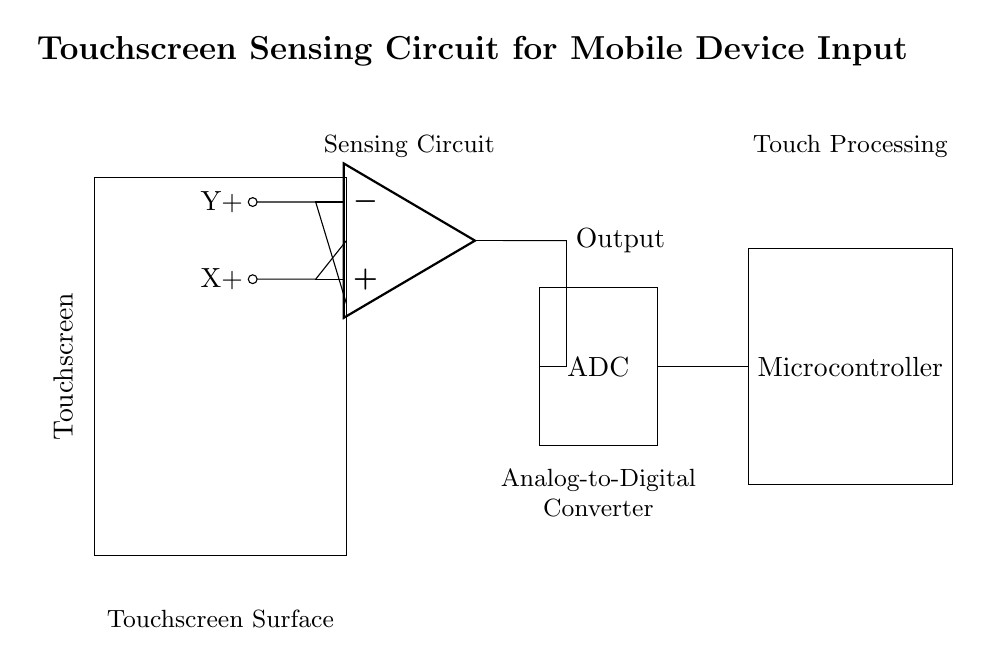What is the main component used for sensing in this circuit? The main component used for sensing is the operational amplifier, which amplifies the signals received from the touchscreen.
Answer: Operational amplifier What is the function of the ADC in this circuit? The ADC (Analog-to-Digital Converter) converts the analog signals outputted by the operational amplifier into digital signals for the microcontroller to process.
Answer: Conversion of signals What are the two input signals connected to the operational amplifier? The two input signals connected to the operational amplifier are X+ and Y+, which correspond to the X and Y coordinates of the touch input.
Answer: X+ and Y+ How does the output from the operational amplifier connect to the ADC? The output from the operational amplifier is connected directly to the ADC through a short connection, allowing for the signal to be processed.
Answer: Direct connection What is the purpose of the microcontroller in this circuit? The microcontroller's purpose is to process the digital signals from the ADC and make decisions based on the touch input from the touchscreen.
Answer: Processing signals 